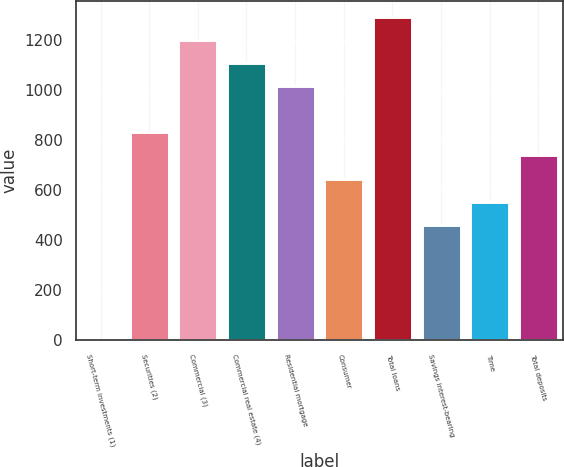<chart> <loc_0><loc_0><loc_500><loc_500><bar_chart><fcel>Short-term investments (1)<fcel>Securities (2)<fcel>Commercial (3)<fcel>Commercial real estate (4)<fcel>Residential mortgage<fcel>Consumer<fcel>Total loans<fcel>Savings interest-bearing<fcel>Time<fcel>Total deposits<nl><fcel>0.3<fcel>831.27<fcel>1200.59<fcel>1108.26<fcel>1015.93<fcel>646.61<fcel>1292.92<fcel>461.95<fcel>554.28<fcel>738.94<nl></chart> 